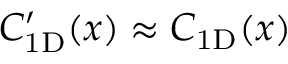Convert formula to latex. <formula><loc_0><loc_0><loc_500><loc_500>C _ { 1 D } ^ { \prime } ( x ) \approx C _ { 1 D } ( x )</formula> 